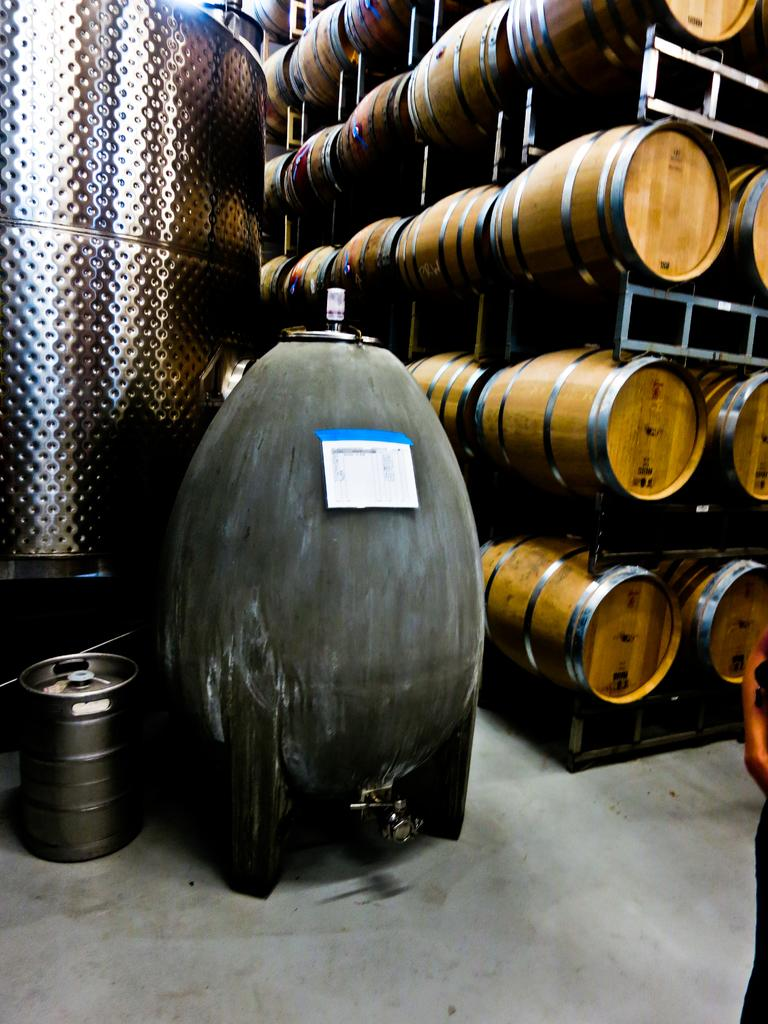What type of storage or display units are present in the image? There are shelves in the image. What items are placed on the shelves? There are drums on the shelves. Is there a drum located elsewhere in the image? Yes, there is a drum on the floor. Who is the creator of the soda in the image? There is no soda present in the image, so it is not possible to determine the creator. 